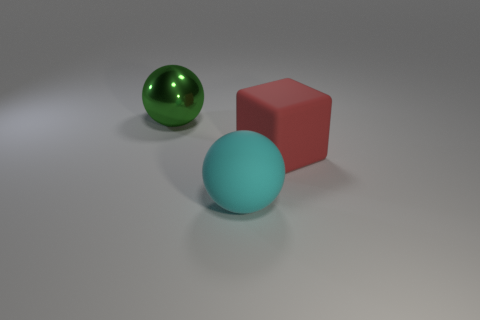Add 1 large objects. How many objects exist? 4 Subtract all spheres. How many objects are left? 1 Add 2 large gray objects. How many large gray objects exist? 2 Subtract 0 cyan cylinders. How many objects are left? 3 Subtract all green metallic objects. Subtract all cyan objects. How many objects are left? 1 Add 3 cyan objects. How many cyan objects are left? 4 